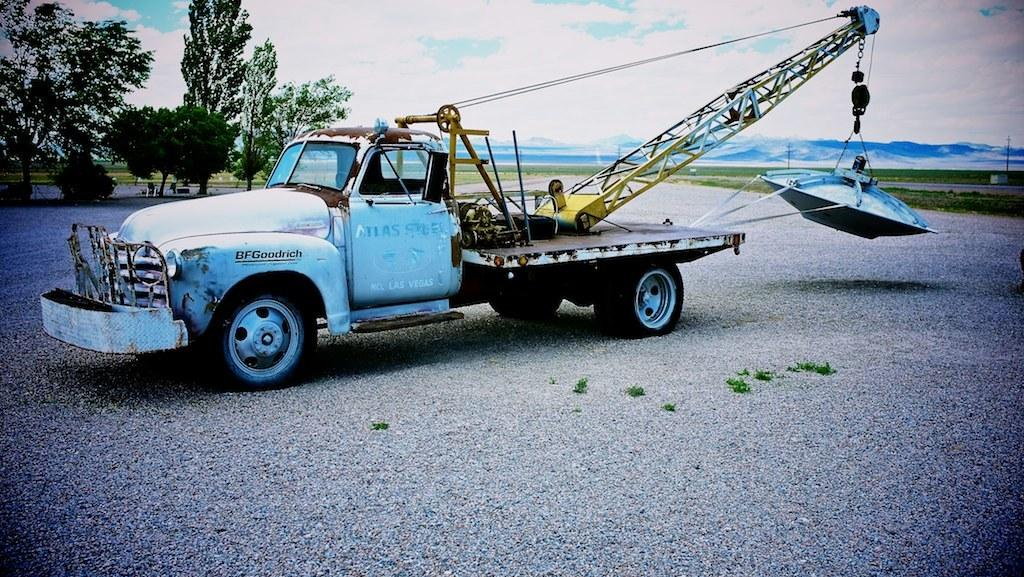What type of vehicle is on the ground in the image? There is a vehicle with a crane on the ground in the image. What is the crane doing in the image? The crane is holding an object in the image. What can be seen in the background of the image? There are trees, electric poles, and mountains in the background of the image. What is visible in the sky in the image? Clouds are visible in the sky in the image. What type of wool is being spun by the vehicle in the image? There is no wool or spinning activity present in the image. The vehicle has a crane that is holding an object, but there is no mention of wool or spinning. 